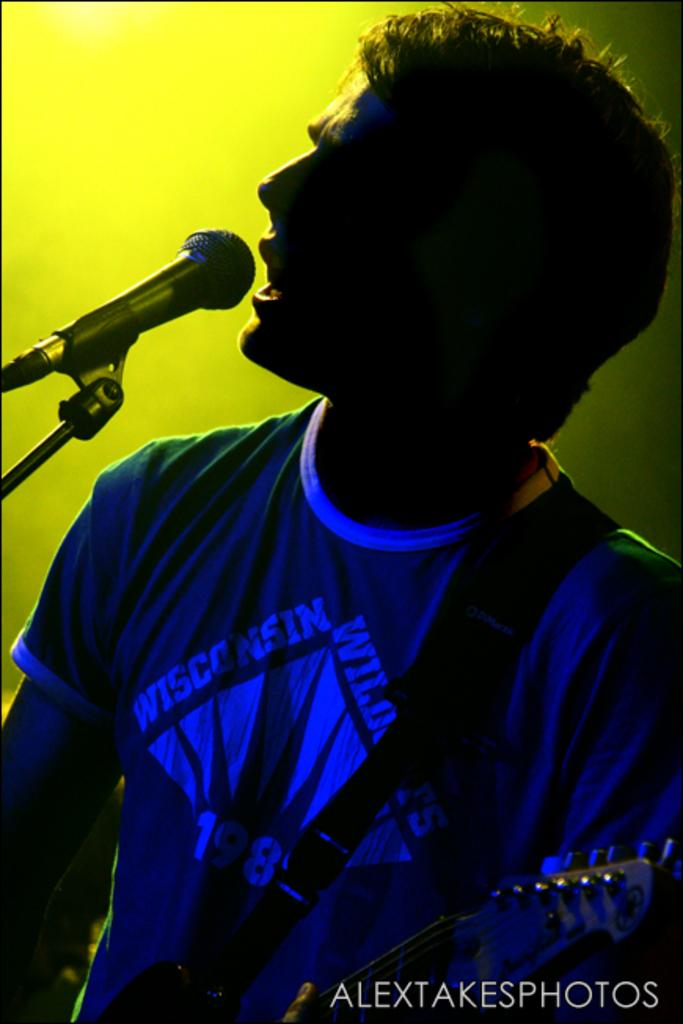What is the main subject of the image? The main subject of the image is a man. What is the man doing in the image? The man is standing and singing in the image. What is the man using to amplify his voice? The man is using a microphone in the image. What color is the background behind the man? The background behind the man is yellow. What type of library can be seen in the background of the image? There is no library present in the image; it features a man singing with a yellow background. What sound is the man making in the image? The man is singing in the image, but we cannot determine the specific sound or melody from the image alone. 